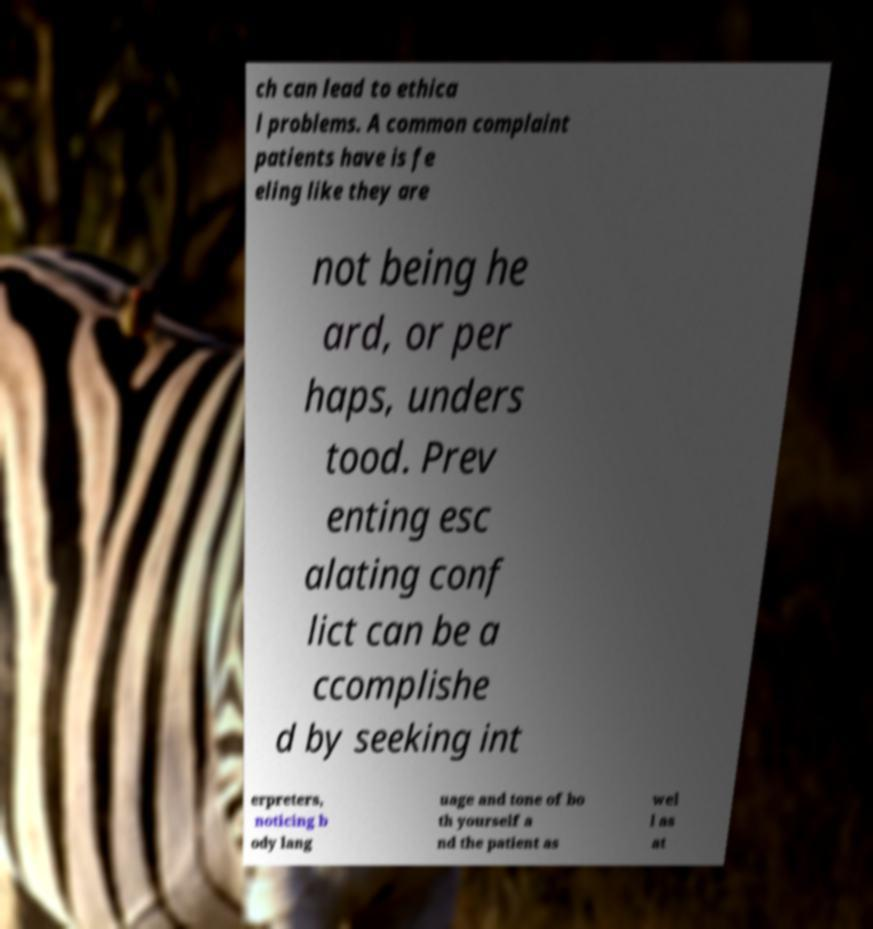There's text embedded in this image that I need extracted. Can you transcribe it verbatim? ch can lead to ethica l problems. A common complaint patients have is fe eling like they are not being he ard, or per haps, unders tood. Prev enting esc alating conf lict can be a ccomplishe d by seeking int erpreters, noticing b ody lang uage and tone of bo th yourself a nd the patient as wel l as at 